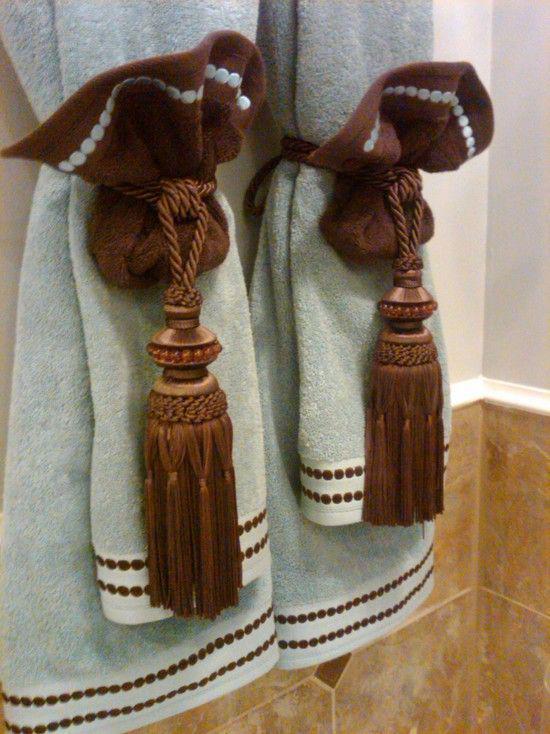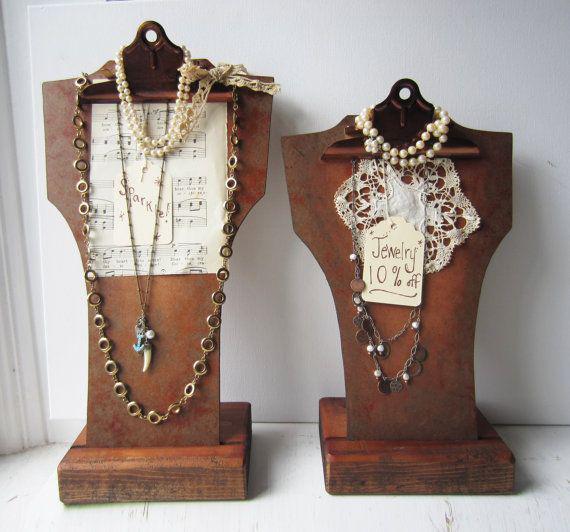The first image is the image on the left, the second image is the image on the right. For the images displayed, is the sentence "Right image features side-by-side towels arranged decoratively on a bar." factually correct? Answer yes or no. No. The first image is the image on the left, the second image is the image on the right. Considering the images on both sides, is "A picture is hanging on the wall above some towels." valid? Answer yes or no. No. 